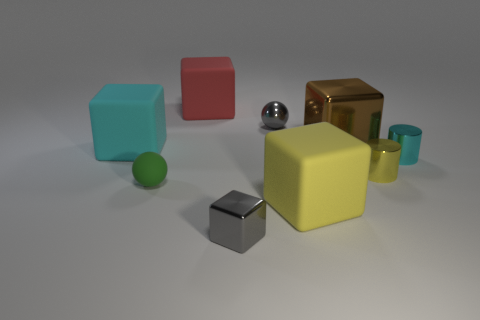Subtract all cyan cubes. How many cubes are left? 4 Subtract 2 blocks. How many blocks are left? 3 Subtract all large yellow blocks. How many blocks are left? 4 Subtract all green cubes. Subtract all green balls. How many cubes are left? 5 Subtract all spheres. How many objects are left? 7 Add 1 big shiny objects. How many big shiny objects are left? 2 Add 5 yellow cylinders. How many yellow cylinders exist? 6 Subtract 1 yellow blocks. How many objects are left? 8 Subtract all small gray cubes. Subtract all yellow matte things. How many objects are left? 7 